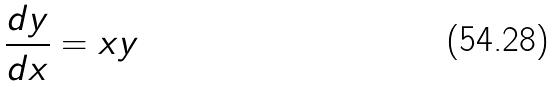<formula> <loc_0><loc_0><loc_500><loc_500>\frac { d y } { d x } = x y</formula> 